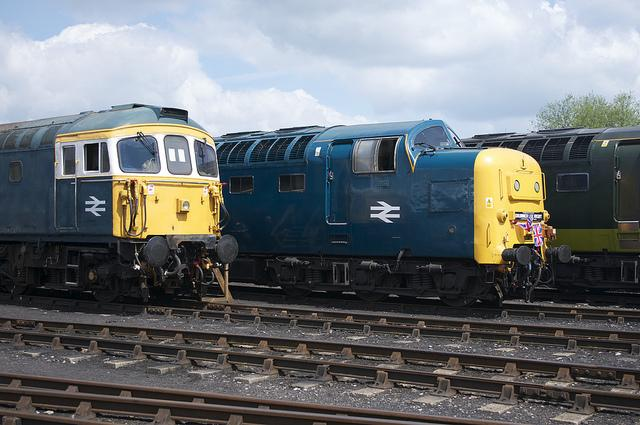The front of the vehicle is mostly the color of what?

Choices:
A) cherry
B) tangerine
C) lime
D) mustard mustard 